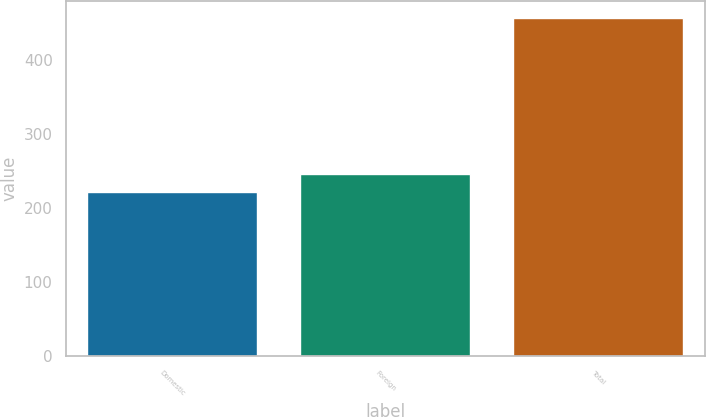Convert chart to OTSL. <chart><loc_0><loc_0><loc_500><loc_500><bar_chart><fcel>Domestic<fcel>Foreign<fcel>Total<nl><fcel>221.8<fcel>245.22<fcel>456<nl></chart> 